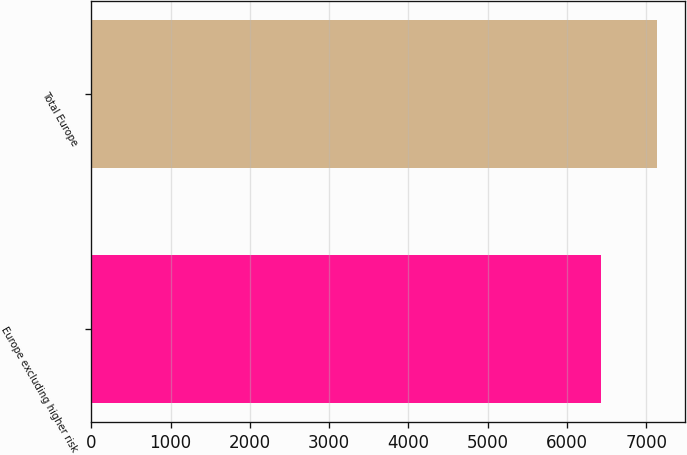Convert chart to OTSL. <chart><loc_0><loc_0><loc_500><loc_500><bar_chart><fcel>Europe excluding higher risk<fcel>Total Europe<nl><fcel>6433<fcel>7136<nl></chart> 